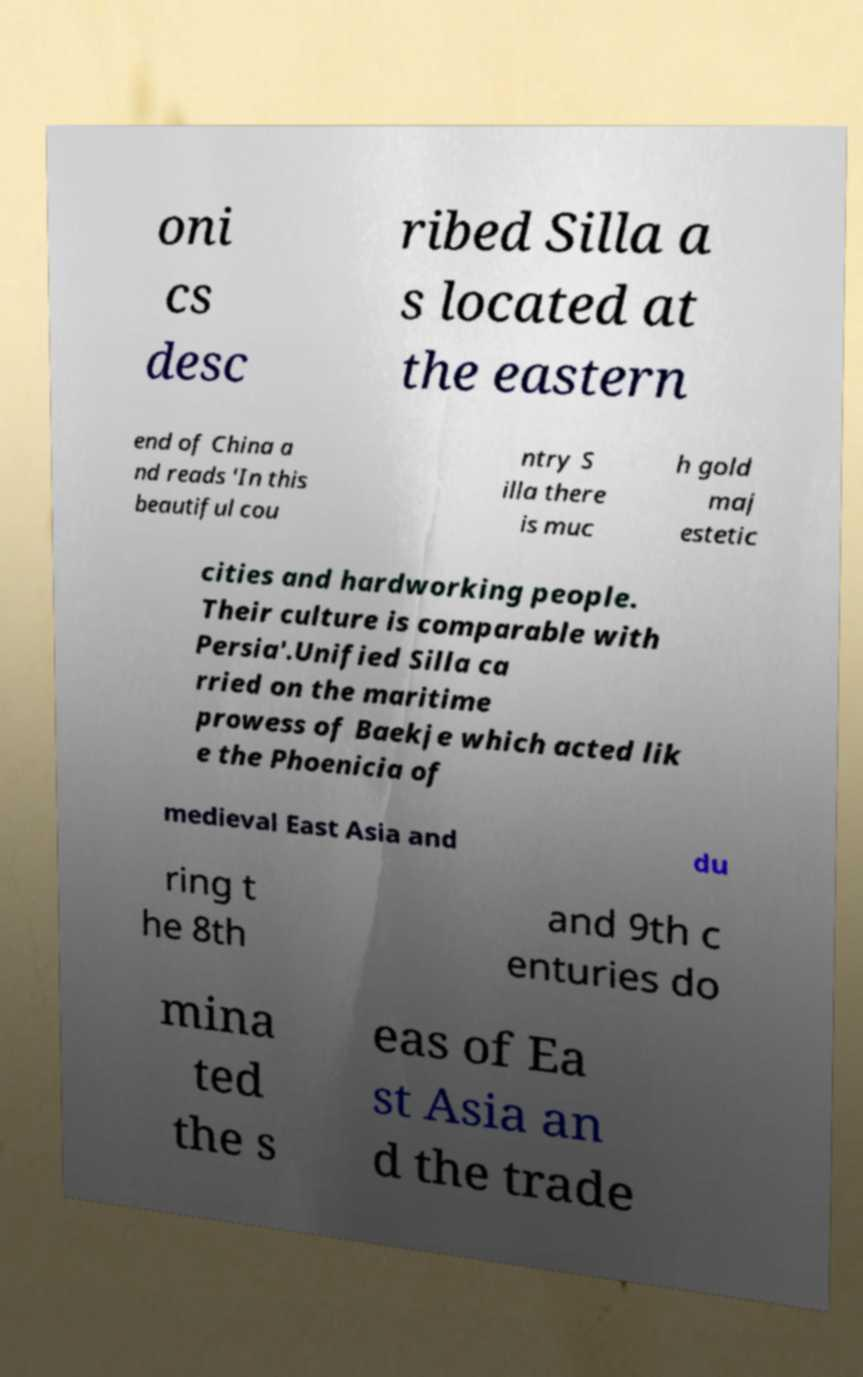Could you assist in decoding the text presented in this image and type it out clearly? oni cs desc ribed Silla a s located at the eastern end of China a nd reads 'In this beautiful cou ntry S illa there is muc h gold maj estetic cities and hardworking people. Their culture is comparable with Persia'.Unified Silla ca rried on the maritime prowess of Baekje which acted lik e the Phoenicia of medieval East Asia and du ring t he 8th and 9th c enturies do mina ted the s eas of Ea st Asia an d the trade 